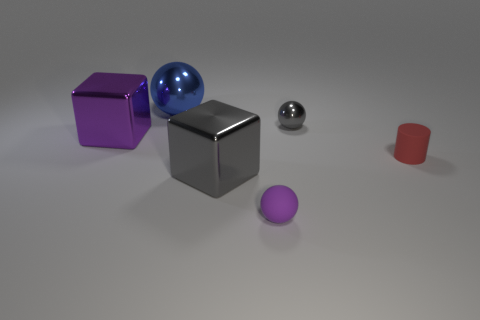Subtract all blue balls. How many balls are left? 2 Subtract 3 spheres. How many spheres are left? 0 Add 3 small rubber spheres. How many objects exist? 9 Subtract all gray cubes. How many cubes are left? 1 Add 3 large blocks. How many large blocks exist? 5 Subtract 0 green spheres. How many objects are left? 6 Subtract all blocks. How many objects are left? 4 Subtract all purple spheres. Subtract all brown cylinders. How many spheres are left? 2 Subtract all yellow cylinders. How many purple spheres are left? 1 Subtract all tiny yellow shiny cylinders. Subtract all big gray blocks. How many objects are left? 5 